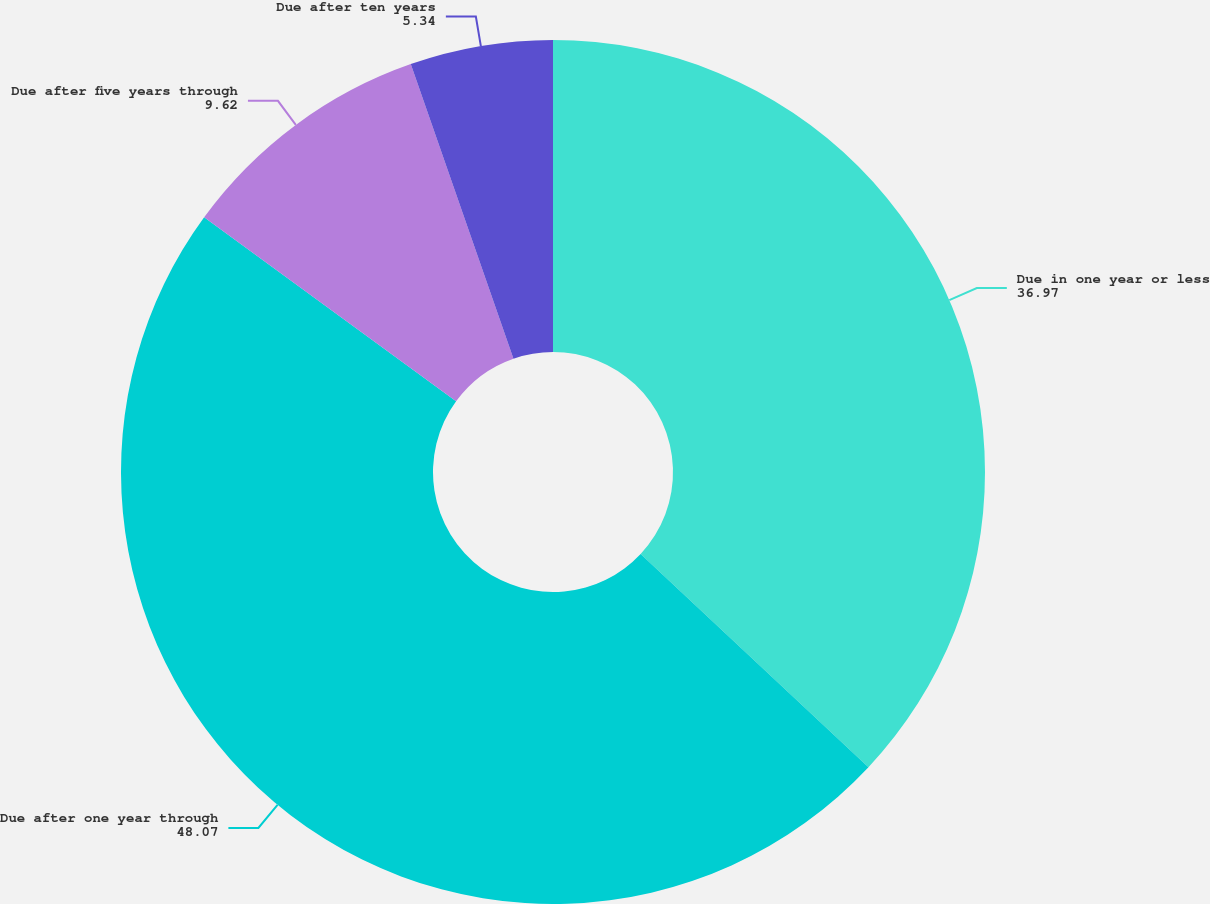Convert chart. <chart><loc_0><loc_0><loc_500><loc_500><pie_chart><fcel>Due in one year or less<fcel>Due after one year through<fcel>Due after five years through<fcel>Due after ten years<nl><fcel>36.97%<fcel>48.07%<fcel>9.62%<fcel>5.34%<nl></chart> 